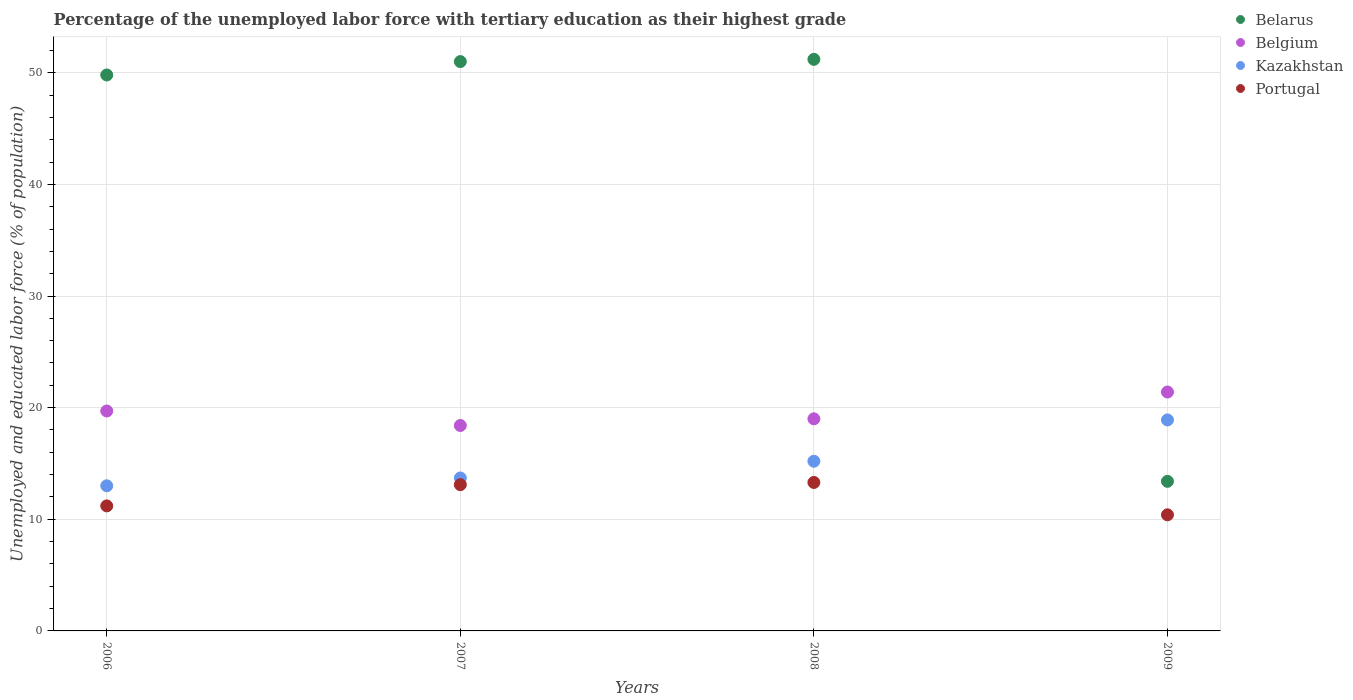Is the number of dotlines equal to the number of legend labels?
Ensure brevity in your answer.  Yes. What is the percentage of the unemployed labor force with tertiary education in Portugal in 2007?
Provide a succinct answer. 13.1. Across all years, what is the maximum percentage of the unemployed labor force with tertiary education in Kazakhstan?
Give a very brief answer. 18.9. Across all years, what is the minimum percentage of the unemployed labor force with tertiary education in Belarus?
Offer a very short reply. 13.4. In which year was the percentage of the unemployed labor force with tertiary education in Belgium maximum?
Give a very brief answer. 2009. In which year was the percentage of the unemployed labor force with tertiary education in Kazakhstan minimum?
Provide a short and direct response. 2006. What is the total percentage of the unemployed labor force with tertiary education in Belarus in the graph?
Your answer should be compact. 165.4. What is the difference between the percentage of the unemployed labor force with tertiary education in Belgium in 2006 and that in 2009?
Provide a succinct answer. -1.7. What is the difference between the percentage of the unemployed labor force with tertiary education in Belarus in 2007 and the percentage of the unemployed labor force with tertiary education in Belgium in 2009?
Give a very brief answer. 29.6. What is the average percentage of the unemployed labor force with tertiary education in Portugal per year?
Make the answer very short. 12. In the year 2006, what is the difference between the percentage of the unemployed labor force with tertiary education in Belarus and percentage of the unemployed labor force with tertiary education in Kazakhstan?
Offer a terse response. 36.8. What is the ratio of the percentage of the unemployed labor force with tertiary education in Kazakhstan in 2007 to that in 2008?
Your response must be concise. 0.9. Is the percentage of the unemployed labor force with tertiary education in Portugal in 2007 less than that in 2008?
Your answer should be very brief. Yes. Is the difference between the percentage of the unemployed labor force with tertiary education in Belarus in 2007 and 2008 greater than the difference between the percentage of the unemployed labor force with tertiary education in Kazakhstan in 2007 and 2008?
Keep it short and to the point. Yes. What is the difference between the highest and the second highest percentage of the unemployed labor force with tertiary education in Belgium?
Offer a terse response. 1.7. What is the difference between the highest and the lowest percentage of the unemployed labor force with tertiary education in Belarus?
Provide a short and direct response. 37.8. How many dotlines are there?
Make the answer very short. 4. What is the difference between two consecutive major ticks on the Y-axis?
Your answer should be very brief. 10. Does the graph contain any zero values?
Your answer should be compact. No. Does the graph contain grids?
Offer a very short reply. Yes. Where does the legend appear in the graph?
Provide a short and direct response. Top right. How are the legend labels stacked?
Give a very brief answer. Vertical. What is the title of the graph?
Ensure brevity in your answer.  Percentage of the unemployed labor force with tertiary education as their highest grade. Does "Ireland" appear as one of the legend labels in the graph?
Offer a very short reply. No. What is the label or title of the X-axis?
Your answer should be very brief. Years. What is the label or title of the Y-axis?
Your answer should be very brief. Unemployed and educated labor force (% of population). What is the Unemployed and educated labor force (% of population) in Belarus in 2006?
Make the answer very short. 49.8. What is the Unemployed and educated labor force (% of population) in Belgium in 2006?
Your answer should be very brief. 19.7. What is the Unemployed and educated labor force (% of population) in Portugal in 2006?
Make the answer very short. 11.2. What is the Unemployed and educated labor force (% of population) of Belgium in 2007?
Your response must be concise. 18.4. What is the Unemployed and educated labor force (% of population) in Kazakhstan in 2007?
Offer a terse response. 13.7. What is the Unemployed and educated labor force (% of population) of Portugal in 2007?
Provide a short and direct response. 13.1. What is the Unemployed and educated labor force (% of population) of Belarus in 2008?
Give a very brief answer. 51.2. What is the Unemployed and educated labor force (% of population) in Belgium in 2008?
Provide a succinct answer. 19. What is the Unemployed and educated labor force (% of population) of Kazakhstan in 2008?
Your response must be concise. 15.2. What is the Unemployed and educated labor force (% of population) in Portugal in 2008?
Give a very brief answer. 13.3. What is the Unemployed and educated labor force (% of population) in Belarus in 2009?
Give a very brief answer. 13.4. What is the Unemployed and educated labor force (% of population) in Belgium in 2009?
Your answer should be compact. 21.4. What is the Unemployed and educated labor force (% of population) of Kazakhstan in 2009?
Provide a short and direct response. 18.9. What is the Unemployed and educated labor force (% of population) of Portugal in 2009?
Offer a terse response. 10.4. Across all years, what is the maximum Unemployed and educated labor force (% of population) of Belarus?
Make the answer very short. 51.2. Across all years, what is the maximum Unemployed and educated labor force (% of population) in Belgium?
Ensure brevity in your answer.  21.4. Across all years, what is the maximum Unemployed and educated labor force (% of population) of Kazakhstan?
Make the answer very short. 18.9. Across all years, what is the maximum Unemployed and educated labor force (% of population) in Portugal?
Your answer should be compact. 13.3. Across all years, what is the minimum Unemployed and educated labor force (% of population) of Belarus?
Keep it short and to the point. 13.4. Across all years, what is the minimum Unemployed and educated labor force (% of population) in Belgium?
Ensure brevity in your answer.  18.4. Across all years, what is the minimum Unemployed and educated labor force (% of population) in Portugal?
Offer a terse response. 10.4. What is the total Unemployed and educated labor force (% of population) of Belarus in the graph?
Give a very brief answer. 165.4. What is the total Unemployed and educated labor force (% of population) in Belgium in the graph?
Provide a short and direct response. 78.5. What is the total Unemployed and educated labor force (% of population) of Kazakhstan in the graph?
Offer a very short reply. 60.8. What is the difference between the Unemployed and educated labor force (% of population) of Belgium in 2006 and that in 2007?
Provide a short and direct response. 1.3. What is the difference between the Unemployed and educated labor force (% of population) in Belarus in 2006 and that in 2008?
Ensure brevity in your answer.  -1.4. What is the difference between the Unemployed and educated labor force (% of population) of Belarus in 2006 and that in 2009?
Provide a short and direct response. 36.4. What is the difference between the Unemployed and educated labor force (% of population) of Kazakhstan in 2006 and that in 2009?
Your answer should be compact. -5.9. What is the difference between the Unemployed and educated labor force (% of population) in Portugal in 2006 and that in 2009?
Offer a very short reply. 0.8. What is the difference between the Unemployed and educated labor force (% of population) in Belgium in 2007 and that in 2008?
Keep it short and to the point. -0.6. What is the difference between the Unemployed and educated labor force (% of population) in Kazakhstan in 2007 and that in 2008?
Make the answer very short. -1.5. What is the difference between the Unemployed and educated labor force (% of population) in Belarus in 2007 and that in 2009?
Provide a short and direct response. 37.6. What is the difference between the Unemployed and educated labor force (% of population) in Belgium in 2007 and that in 2009?
Keep it short and to the point. -3. What is the difference between the Unemployed and educated labor force (% of population) of Kazakhstan in 2007 and that in 2009?
Keep it short and to the point. -5.2. What is the difference between the Unemployed and educated labor force (% of population) in Portugal in 2007 and that in 2009?
Offer a very short reply. 2.7. What is the difference between the Unemployed and educated labor force (% of population) in Belarus in 2008 and that in 2009?
Offer a very short reply. 37.8. What is the difference between the Unemployed and educated labor force (% of population) of Kazakhstan in 2008 and that in 2009?
Your answer should be very brief. -3.7. What is the difference between the Unemployed and educated labor force (% of population) of Portugal in 2008 and that in 2009?
Make the answer very short. 2.9. What is the difference between the Unemployed and educated labor force (% of population) of Belarus in 2006 and the Unemployed and educated labor force (% of population) of Belgium in 2007?
Your answer should be compact. 31.4. What is the difference between the Unemployed and educated labor force (% of population) in Belarus in 2006 and the Unemployed and educated labor force (% of population) in Kazakhstan in 2007?
Make the answer very short. 36.1. What is the difference between the Unemployed and educated labor force (% of population) of Belarus in 2006 and the Unemployed and educated labor force (% of population) of Portugal in 2007?
Give a very brief answer. 36.7. What is the difference between the Unemployed and educated labor force (% of population) in Belgium in 2006 and the Unemployed and educated labor force (% of population) in Kazakhstan in 2007?
Provide a succinct answer. 6. What is the difference between the Unemployed and educated labor force (% of population) in Kazakhstan in 2006 and the Unemployed and educated labor force (% of population) in Portugal in 2007?
Your response must be concise. -0.1. What is the difference between the Unemployed and educated labor force (% of population) of Belarus in 2006 and the Unemployed and educated labor force (% of population) of Belgium in 2008?
Offer a very short reply. 30.8. What is the difference between the Unemployed and educated labor force (% of population) in Belarus in 2006 and the Unemployed and educated labor force (% of population) in Kazakhstan in 2008?
Keep it short and to the point. 34.6. What is the difference between the Unemployed and educated labor force (% of population) in Belarus in 2006 and the Unemployed and educated labor force (% of population) in Portugal in 2008?
Provide a succinct answer. 36.5. What is the difference between the Unemployed and educated labor force (% of population) of Kazakhstan in 2006 and the Unemployed and educated labor force (% of population) of Portugal in 2008?
Your answer should be compact. -0.3. What is the difference between the Unemployed and educated labor force (% of population) in Belarus in 2006 and the Unemployed and educated labor force (% of population) in Belgium in 2009?
Your answer should be compact. 28.4. What is the difference between the Unemployed and educated labor force (% of population) in Belarus in 2006 and the Unemployed and educated labor force (% of population) in Kazakhstan in 2009?
Your answer should be compact. 30.9. What is the difference between the Unemployed and educated labor force (% of population) in Belarus in 2006 and the Unemployed and educated labor force (% of population) in Portugal in 2009?
Ensure brevity in your answer.  39.4. What is the difference between the Unemployed and educated labor force (% of population) of Belarus in 2007 and the Unemployed and educated labor force (% of population) of Kazakhstan in 2008?
Give a very brief answer. 35.8. What is the difference between the Unemployed and educated labor force (% of population) of Belarus in 2007 and the Unemployed and educated labor force (% of population) of Portugal in 2008?
Your answer should be very brief. 37.7. What is the difference between the Unemployed and educated labor force (% of population) in Belgium in 2007 and the Unemployed and educated labor force (% of population) in Kazakhstan in 2008?
Your response must be concise. 3.2. What is the difference between the Unemployed and educated labor force (% of population) in Kazakhstan in 2007 and the Unemployed and educated labor force (% of population) in Portugal in 2008?
Offer a very short reply. 0.4. What is the difference between the Unemployed and educated labor force (% of population) of Belarus in 2007 and the Unemployed and educated labor force (% of population) of Belgium in 2009?
Your answer should be very brief. 29.6. What is the difference between the Unemployed and educated labor force (% of population) in Belarus in 2007 and the Unemployed and educated labor force (% of population) in Kazakhstan in 2009?
Ensure brevity in your answer.  32.1. What is the difference between the Unemployed and educated labor force (% of population) of Belarus in 2007 and the Unemployed and educated labor force (% of population) of Portugal in 2009?
Make the answer very short. 40.6. What is the difference between the Unemployed and educated labor force (% of population) in Belarus in 2008 and the Unemployed and educated labor force (% of population) in Belgium in 2009?
Make the answer very short. 29.8. What is the difference between the Unemployed and educated labor force (% of population) in Belarus in 2008 and the Unemployed and educated labor force (% of population) in Kazakhstan in 2009?
Offer a very short reply. 32.3. What is the difference between the Unemployed and educated labor force (% of population) in Belarus in 2008 and the Unemployed and educated labor force (% of population) in Portugal in 2009?
Your answer should be compact. 40.8. What is the difference between the Unemployed and educated labor force (% of population) of Belgium in 2008 and the Unemployed and educated labor force (% of population) of Portugal in 2009?
Keep it short and to the point. 8.6. What is the average Unemployed and educated labor force (% of population) of Belarus per year?
Your answer should be compact. 41.35. What is the average Unemployed and educated labor force (% of population) of Belgium per year?
Your answer should be very brief. 19.62. What is the average Unemployed and educated labor force (% of population) of Kazakhstan per year?
Your answer should be compact. 15.2. In the year 2006, what is the difference between the Unemployed and educated labor force (% of population) in Belarus and Unemployed and educated labor force (% of population) in Belgium?
Your answer should be compact. 30.1. In the year 2006, what is the difference between the Unemployed and educated labor force (% of population) in Belarus and Unemployed and educated labor force (% of population) in Kazakhstan?
Keep it short and to the point. 36.8. In the year 2006, what is the difference between the Unemployed and educated labor force (% of population) of Belarus and Unemployed and educated labor force (% of population) of Portugal?
Your answer should be compact. 38.6. In the year 2006, what is the difference between the Unemployed and educated labor force (% of population) in Belgium and Unemployed and educated labor force (% of population) in Kazakhstan?
Provide a succinct answer. 6.7. In the year 2006, what is the difference between the Unemployed and educated labor force (% of population) of Belgium and Unemployed and educated labor force (% of population) of Portugal?
Ensure brevity in your answer.  8.5. In the year 2007, what is the difference between the Unemployed and educated labor force (% of population) in Belarus and Unemployed and educated labor force (% of population) in Belgium?
Offer a terse response. 32.6. In the year 2007, what is the difference between the Unemployed and educated labor force (% of population) of Belarus and Unemployed and educated labor force (% of population) of Kazakhstan?
Keep it short and to the point. 37.3. In the year 2007, what is the difference between the Unemployed and educated labor force (% of population) of Belarus and Unemployed and educated labor force (% of population) of Portugal?
Offer a terse response. 37.9. In the year 2007, what is the difference between the Unemployed and educated labor force (% of population) in Belgium and Unemployed and educated labor force (% of population) in Portugal?
Provide a short and direct response. 5.3. In the year 2007, what is the difference between the Unemployed and educated labor force (% of population) of Kazakhstan and Unemployed and educated labor force (% of population) of Portugal?
Provide a short and direct response. 0.6. In the year 2008, what is the difference between the Unemployed and educated labor force (% of population) of Belarus and Unemployed and educated labor force (% of population) of Belgium?
Provide a succinct answer. 32.2. In the year 2008, what is the difference between the Unemployed and educated labor force (% of population) of Belarus and Unemployed and educated labor force (% of population) of Portugal?
Ensure brevity in your answer.  37.9. In the year 2008, what is the difference between the Unemployed and educated labor force (% of population) in Belgium and Unemployed and educated labor force (% of population) in Kazakhstan?
Give a very brief answer. 3.8. In the year 2009, what is the difference between the Unemployed and educated labor force (% of population) of Belarus and Unemployed and educated labor force (% of population) of Kazakhstan?
Offer a terse response. -5.5. In the year 2009, what is the difference between the Unemployed and educated labor force (% of population) in Belarus and Unemployed and educated labor force (% of population) in Portugal?
Make the answer very short. 3. In the year 2009, what is the difference between the Unemployed and educated labor force (% of population) of Kazakhstan and Unemployed and educated labor force (% of population) of Portugal?
Offer a very short reply. 8.5. What is the ratio of the Unemployed and educated labor force (% of population) in Belarus in 2006 to that in 2007?
Give a very brief answer. 0.98. What is the ratio of the Unemployed and educated labor force (% of population) of Belgium in 2006 to that in 2007?
Make the answer very short. 1.07. What is the ratio of the Unemployed and educated labor force (% of population) in Kazakhstan in 2006 to that in 2007?
Give a very brief answer. 0.95. What is the ratio of the Unemployed and educated labor force (% of population) of Portugal in 2006 to that in 2007?
Provide a succinct answer. 0.85. What is the ratio of the Unemployed and educated labor force (% of population) in Belarus in 2006 to that in 2008?
Give a very brief answer. 0.97. What is the ratio of the Unemployed and educated labor force (% of population) of Belgium in 2006 to that in 2008?
Give a very brief answer. 1.04. What is the ratio of the Unemployed and educated labor force (% of population) in Kazakhstan in 2006 to that in 2008?
Give a very brief answer. 0.86. What is the ratio of the Unemployed and educated labor force (% of population) of Portugal in 2006 to that in 2008?
Your answer should be very brief. 0.84. What is the ratio of the Unemployed and educated labor force (% of population) in Belarus in 2006 to that in 2009?
Offer a terse response. 3.72. What is the ratio of the Unemployed and educated labor force (% of population) in Belgium in 2006 to that in 2009?
Provide a succinct answer. 0.92. What is the ratio of the Unemployed and educated labor force (% of population) of Kazakhstan in 2006 to that in 2009?
Provide a succinct answer. 0.69. What is the ratio of the Unemployed and educated labor force (% of population) of Portugal in 2006 to that in 2009?
Offer a very short reply. 1.08. What is the ratio of the Unemployed and educated labor force (% of population) of Belarus in 2007 to that in 2008?
Provide a succinct answer. 1. What is the ratio of the Unemployed and educated labor force (% of population) in Belgium in 2007 to that in 2008?
Keep it short and to the point. 0.97. What is the ratio of the Unemployed and educated labor force (% of population) of Kazakhstan in 2007 to that in 2008?
Give a very brief answer. 0.9. What is the ratio of the Unemployed and educated labor force (% of population) in Belarus in 2007 to that in 2009?
Give a very brief answer. 3.81. What is the ratio of the Unemployed and educated labor force (% of population) of Belgium in 2007 to that in 2009?
Your response must be concise. 0.86. What is the ratio of the Unemployed and educated labor force (% of population) of Kazakhstan in 2007 to that in 2009?
Make the answer very short. 0.72. What is the ratio of the Unemployed and educated labor force (% of population) of Portugal in 2007 to that in 2009?
Your answer should be compact. 1.26. What is the ratio of the Unemployed and educated labor force (% of population) in Belarus in 2008 to that in 2009?
Offer a terse response. 3.82. What is the ratio of the Unemployed and educated labor force (% of population) in Belgium in 2008 to that in 2009?
Your answer should be very brief. 0.89. What is the ratio of the Unemployed and educated labor force (% of population) in Kazakhstan in 2008 to that in 2009?
Your answer should be compact. 0.8. What is the ratio of the Unemployed and educated labor force (% of population) of Portugal in 2008 to that in 2009?
Ensure brevity in your answer.  1.28. What is the difference between the highest and the second highest Unemployed and educated labor force (% of population) in Belgium?
Ensure brevity in your answer.  1.7. What is the difference between the highest and the second highest Unemployed and educated labor force (% of population) in Portugal?
Your response must be concise. 0.2. What is the difference between the highest and the lowest Unemployed and educated labor force (% of population) of Belarus?
Offer a terse response. 37.8. What is the difference between the highest and the lowest Unemployed and educated labor force (% of population) in Kazakhstan?
Provide a succinct answer. 5.9. 